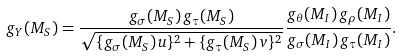Convert formula to latex. <formula><loc_0><loc_0><loc_500><loc_500>g _ { Y } ( M _ { S } ) = \frac { g _ { \sigma } ( M _ { S } ) \, g _ { \tau } ( M _ { S } ) } { \sqrt { \{ g _ { \sigma } ( M _ { S } ) \, u \} ^ { 2 } + \{ g _ { \tau } ( M _ { S } ) \, v \} ^ { 2 } } } \frac { g _ { \theta } ( M _ { I } ) \, g _ { \rho } ( M _ { I } ) } { g _ { \sigma } ( M _ { I } ) \, g _ { \tau } ( M _ { I } ) } .</formula> 